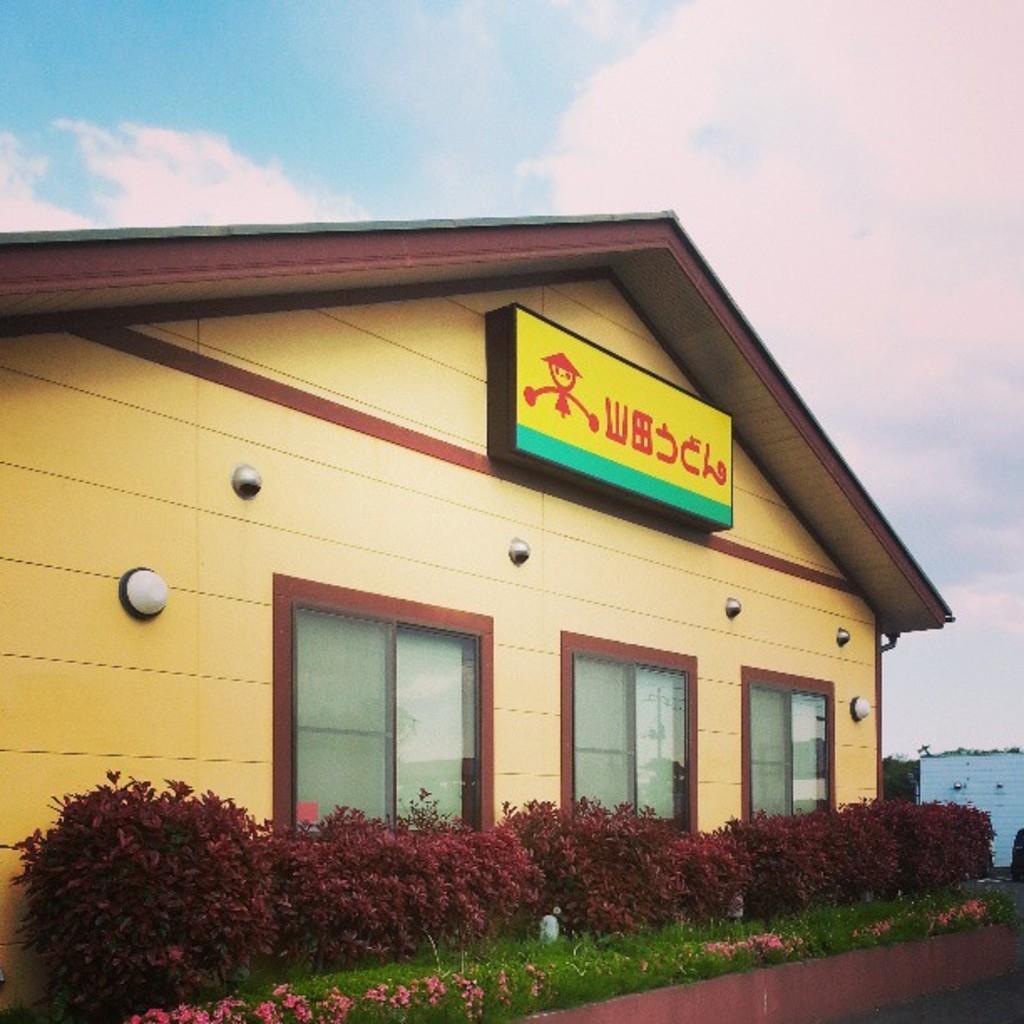Could you give a brief overview of what you see in this image? In this picture I can see the plants and few flowers. In the center of this picture I can see a building and I can see a board on which there is something written and I can see the windows. In the background I can see the sky. 